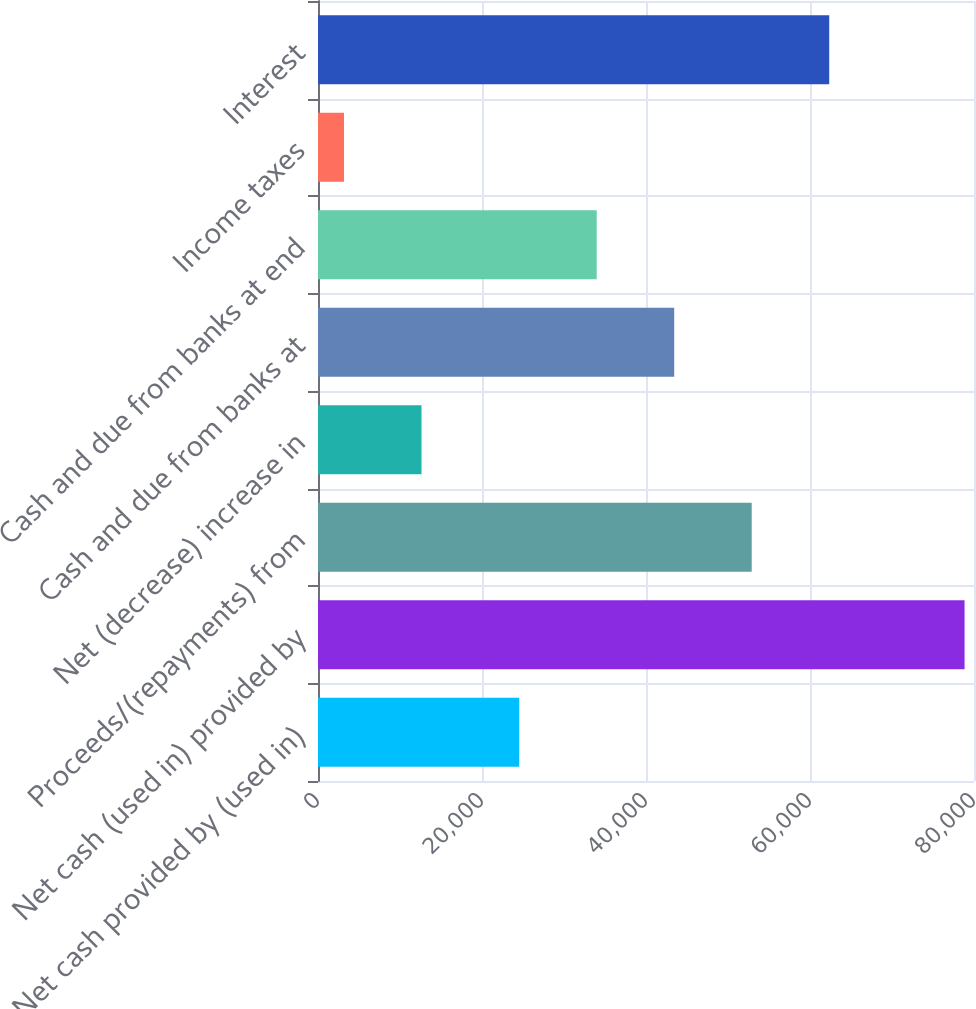Convert chart. <chart><loc_0><loc_0><loc_500><loc_500><bar_chart><fcel>Net cash provided by (used in)<fcel>Net cash (used in) provided by<fcel>Proceeds/(repayments) from<fcel>Net (decrease) increase in<fcel>Cash and due from banks at<fcel>Cash and due from banks at end<fcel>Income taxes<fcel>Interest<nl><fcel>24537<fcel>78850<fcel>52891.8<fcel>12621.6<fcel>43440.2<fcel>33988.6<fcel>3170<fcel>62343.4<nl></chart> 